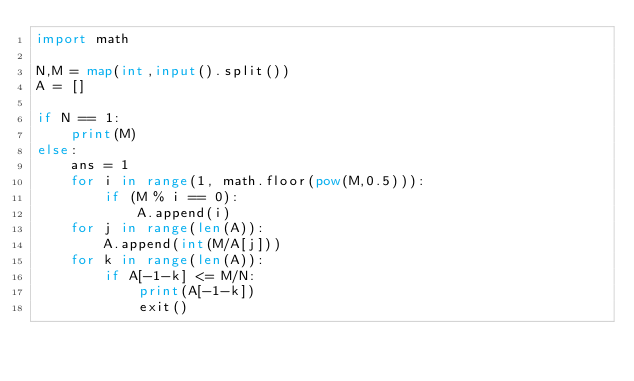Convert code to text. <code><loc_0><loc_0><loc_500><loc_500><_Python_>import math

N,M = map(int,input().split())
A = []

if N == 1:
    print(M)
else:
    ans = 1
    for i in range(1, math.floor(pow(M,0.5))):
        if (M % i == 0):
            A.append(i)
    for j in range(len(A)):
        A.append(int(M/A[j]))
    for k in range(len(A)):
        if A[-1-k] <= M/N:
            print(A[-1-k])
            exit()</code> 